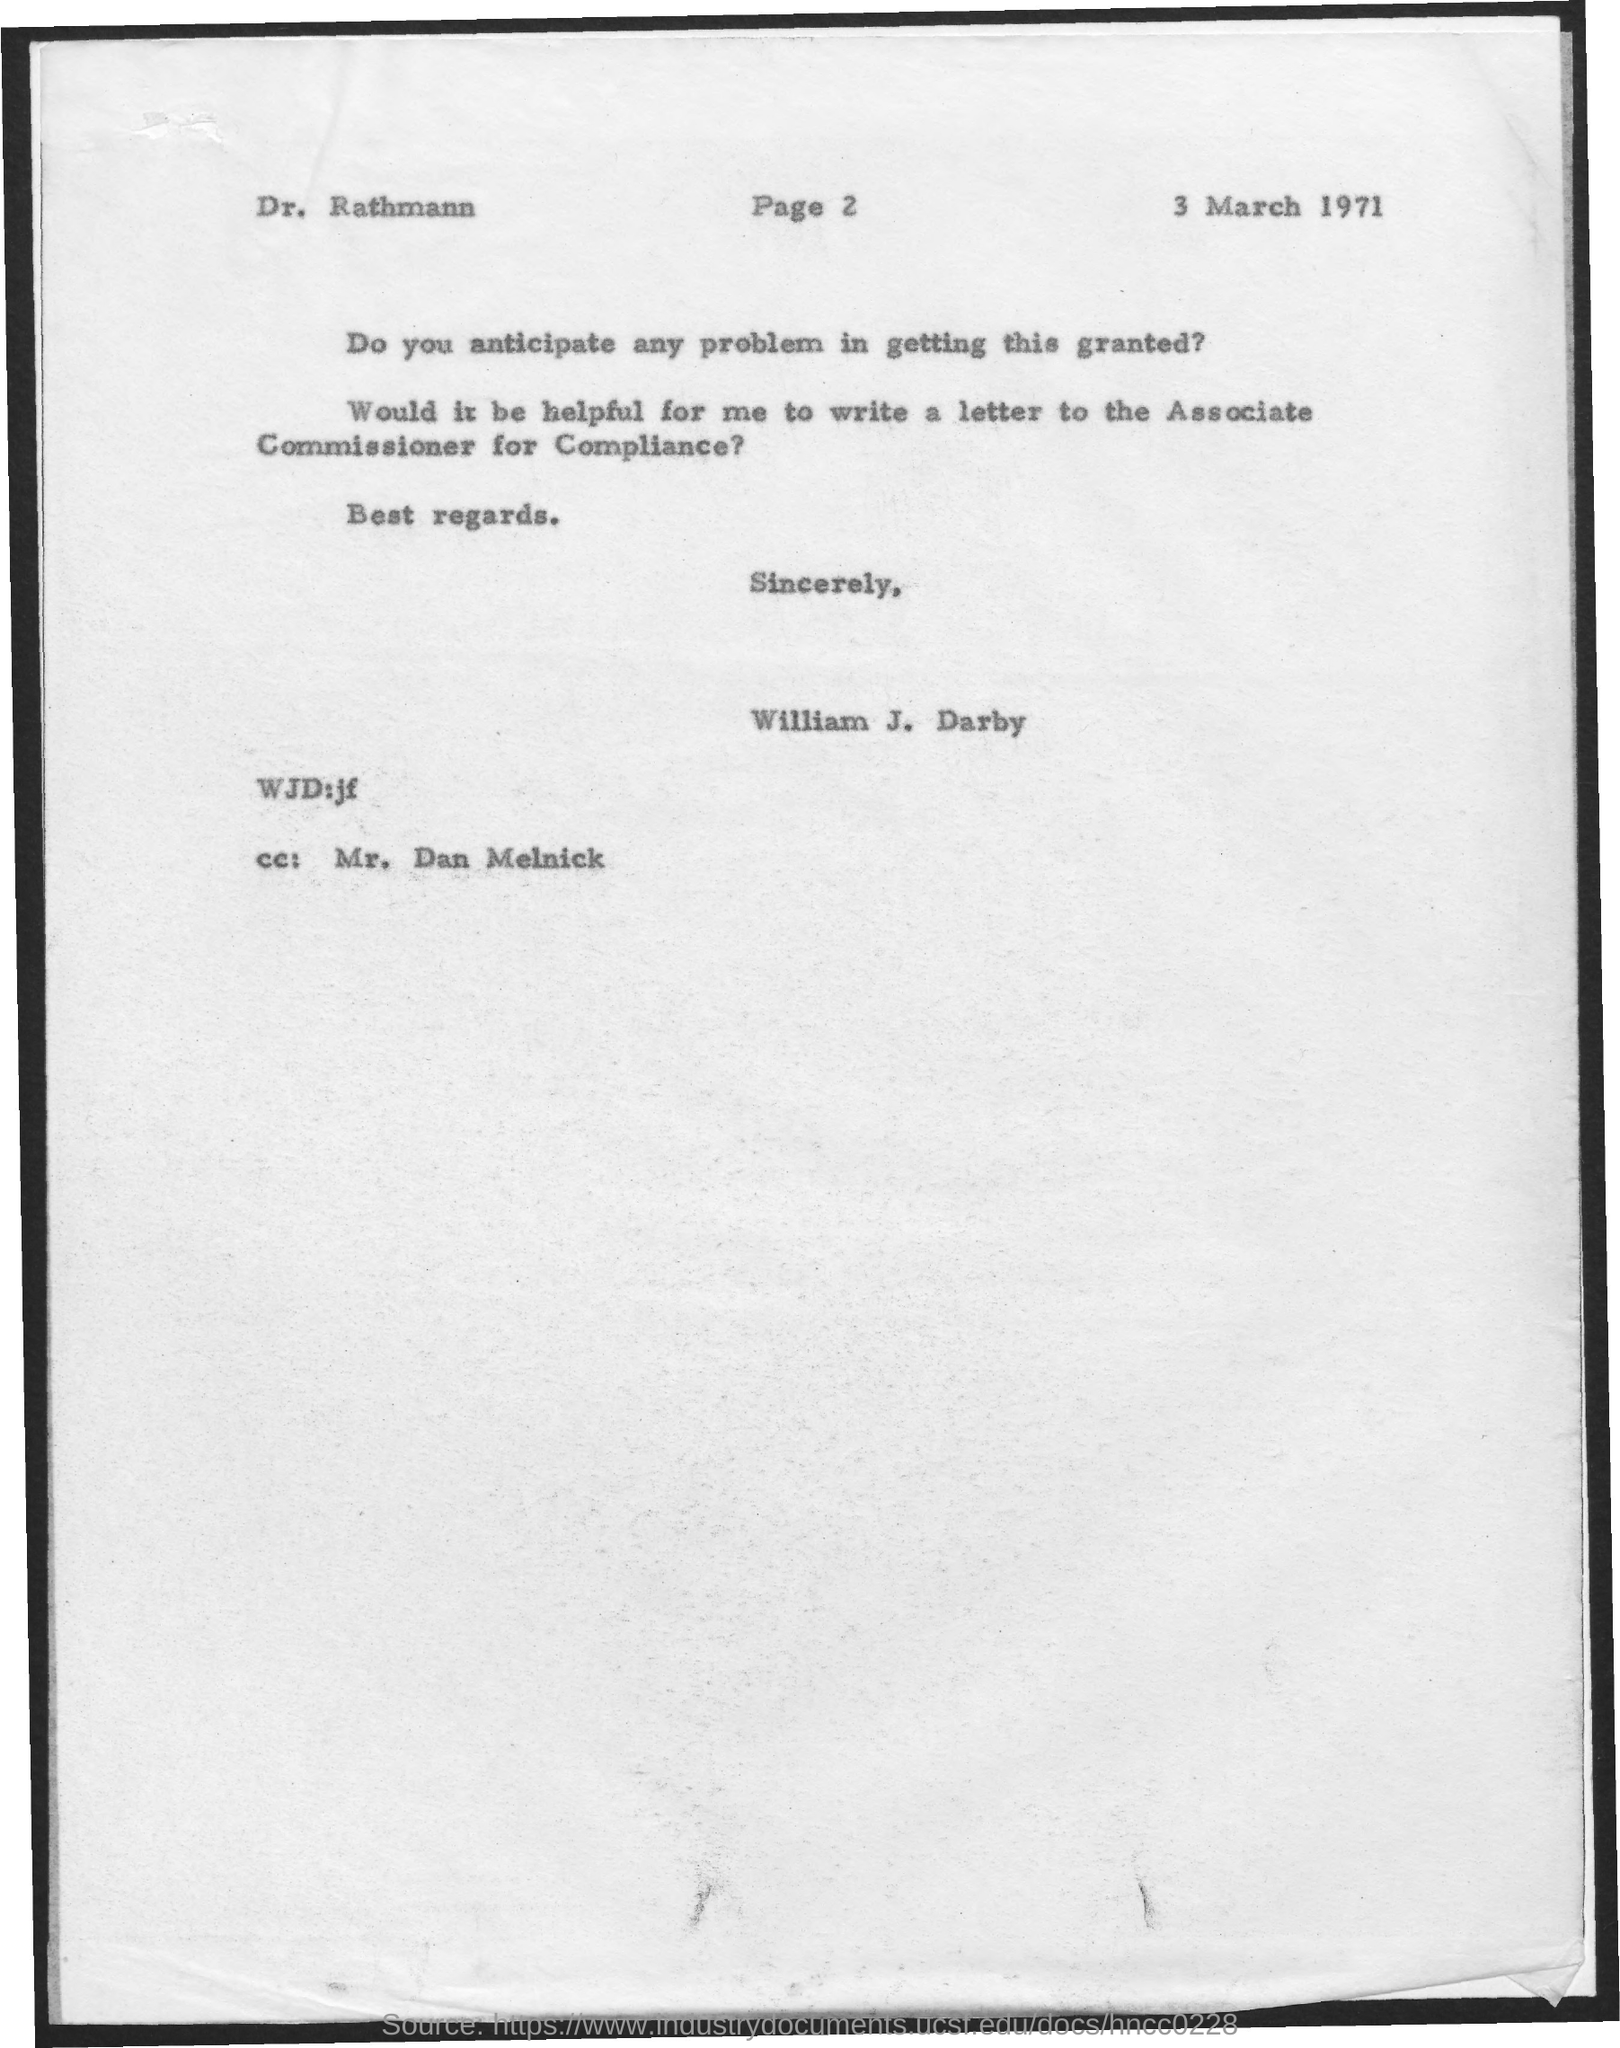What is the date on the document?
Your answer should be very brief. 3 MARCH 1971. To Whom is this letter addressed to?
Ensure brevity in your answer.  Dr. Rathmann. Who is this letter from?
Offer a very short reply. William J. Darby. Who is the cc:?
Your response must be concise. MR. DAN MELNICK. 